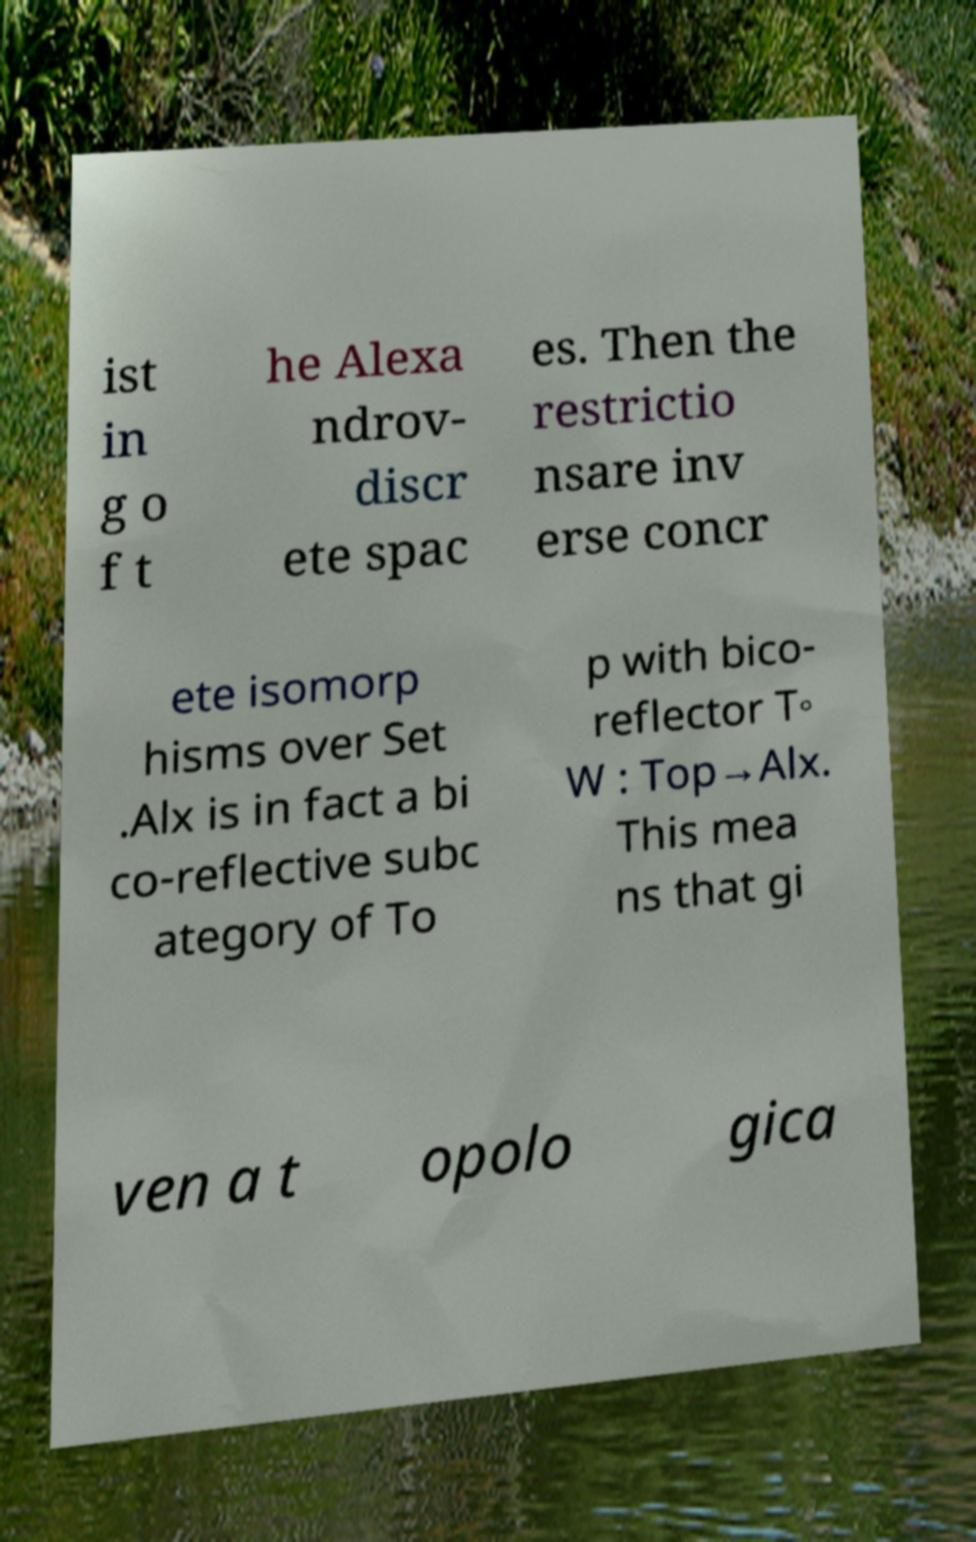Please read and relay the text visible in this image. What does it say? ist in g o f t he Alexa ndrov- discr ete spac es. Then the restrictio nsare inv erse concr ete isomorp hisms over Set .Alx is in fact a bi co-reflective subc ategory of To p with bico- reflector T◦ W : Top→Alx. This mea ns that gi ven a t opolo gica 